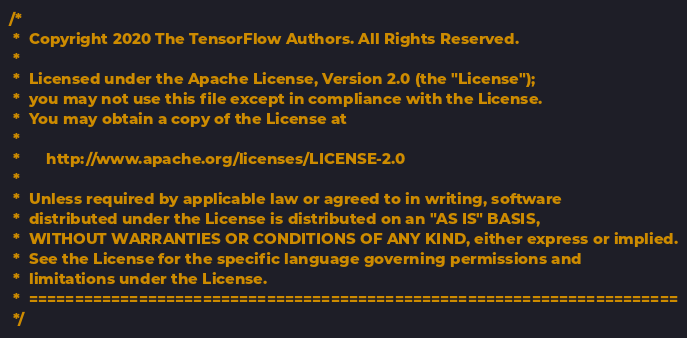Convert code to text. <code><loc_0><loc_0><loc_500><loc_500><_Java_>/*
 *  Copyright 2020 The TensorFlow Authors. All Rights Reserved.
 *
 *  Licensed under the Apache License, Version 2.0 (the "License");
 *  you may not use this file except in compliance with the License.
 *  You may obtain a copy of the License at
 *
 *      http://www.apache.org/licenses/LICENSE-2.0
 *
 *  Unless required by applicable law or agreed to in writing, software
 *  distributed under the License is distributed on an "AS IS" BASIS,
 *  WITHOUT WARRANTIES OR CONDITIONS OF ANY KIND, either express or implied.
 *  See the License for the specific language governing permissions and
 *  limitations under the License.
 *  =======================================================================
 */</code> 